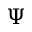<formula> <loc_0><loc_0><loc_500><loc_500>\Psi</formula> 